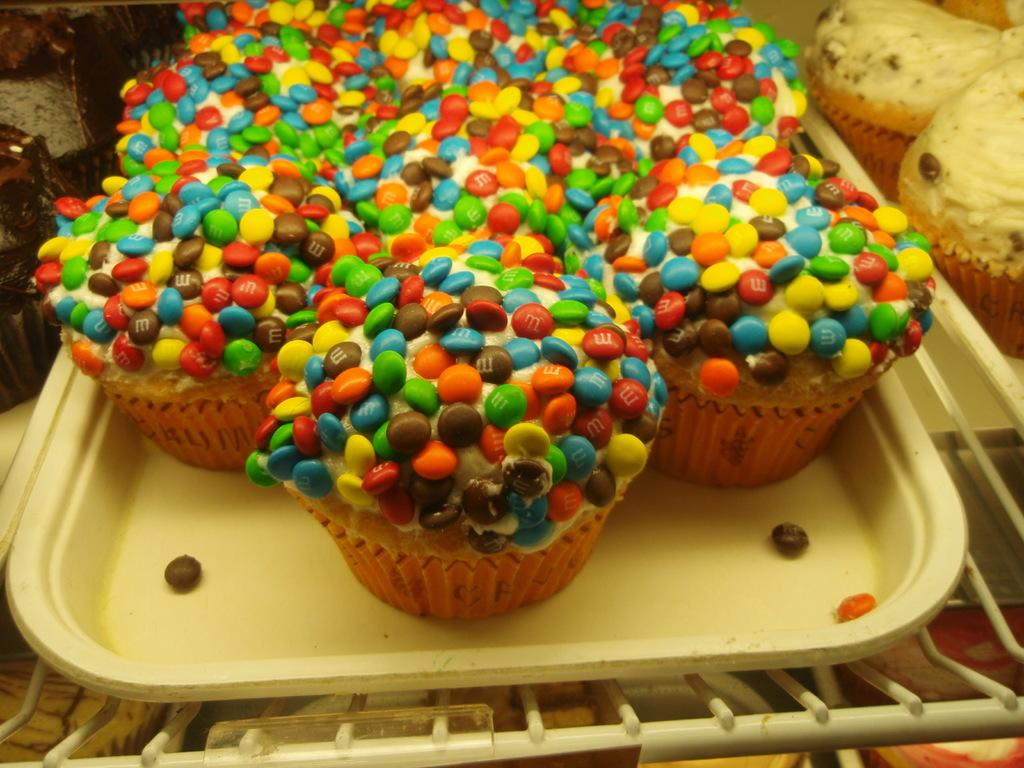What type of food is visible in the image? There are cupcakes in the image. How are the cupcakes arranged or displayed? The cupcakes are on trays. What color is the neck of the person in the image? There is no person present in the image, only cupcakes on trays. 